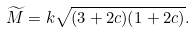Convert formula to latex. <formula><loc_0><loc_0><loc_500><loc_500>\widetilde { M } = k \sqrt { ( 3 + 2 c ) ( 1 + 2 c ) } .</formula> 